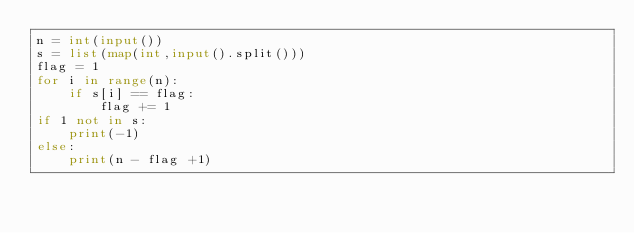<code> <loc_0><loc_0><loc_500><loc_500><_Python_>n = int(input())
s = list(map(int,input().split()))
flag = 1
for i in range(n):
    if s[i] == flag:
        flag += 1
if 1 not in s:
    print(-1)
else:
    print(n - flag +1)</code> 